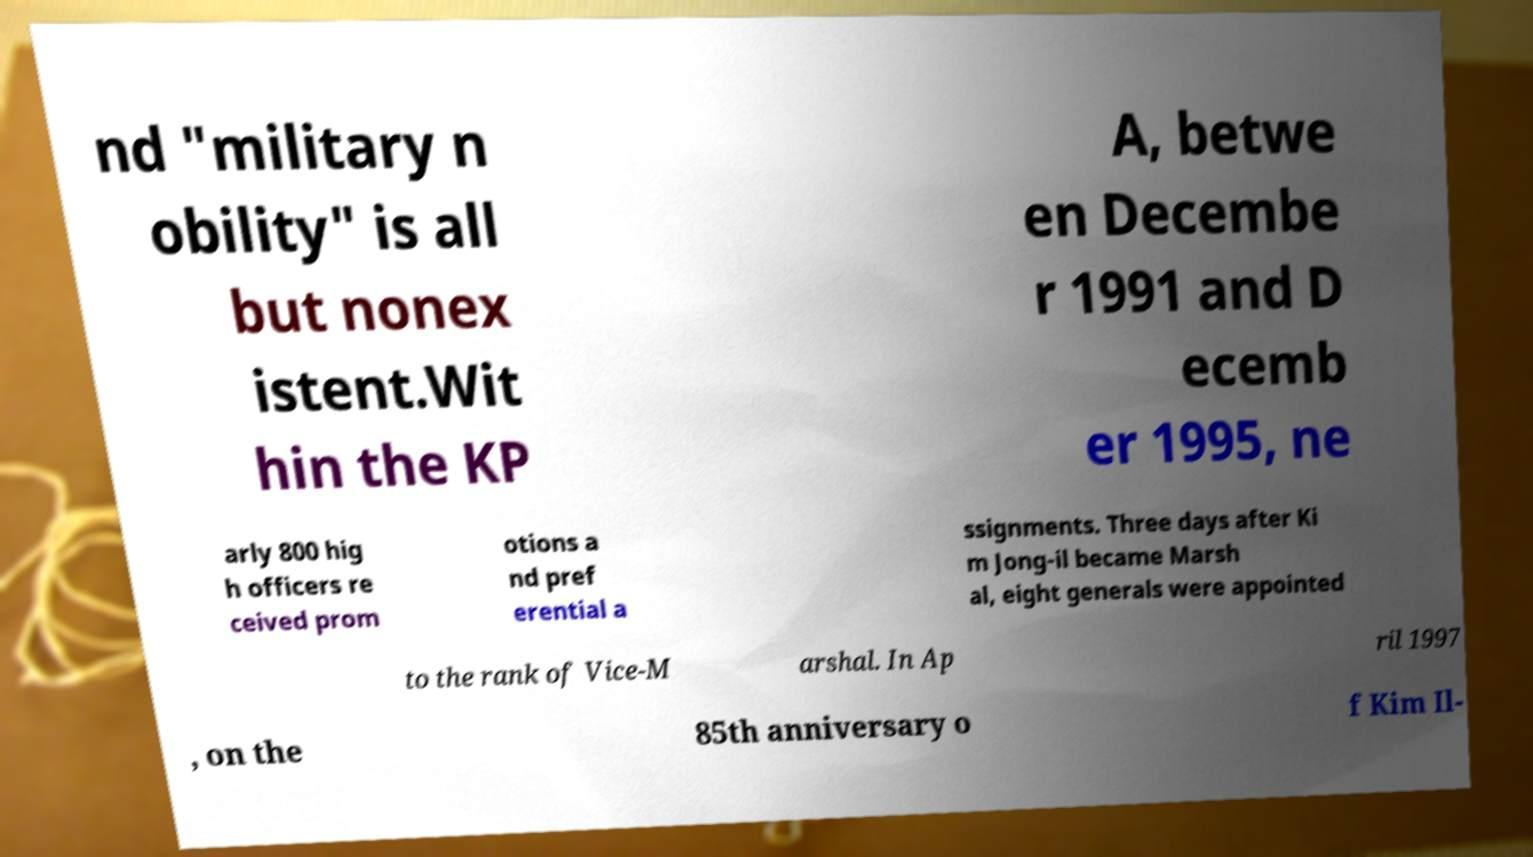Can you accurately transcribe the text from the provided image for me? nd "military n obility" is all but nonex istent.Wit hin the KP A, betwe en Decembe r 1991 and D ecemb er 1995, ne arly 800 hig h officers re ceived prom otions a nd pref erential a ssignments. Three days after Ki m Jong-il became Marsh al, eight generals were appointed to the rank of Vice-M arshal. In Ap ril 1997 , on the 85th anniversary o f Kim Il- 